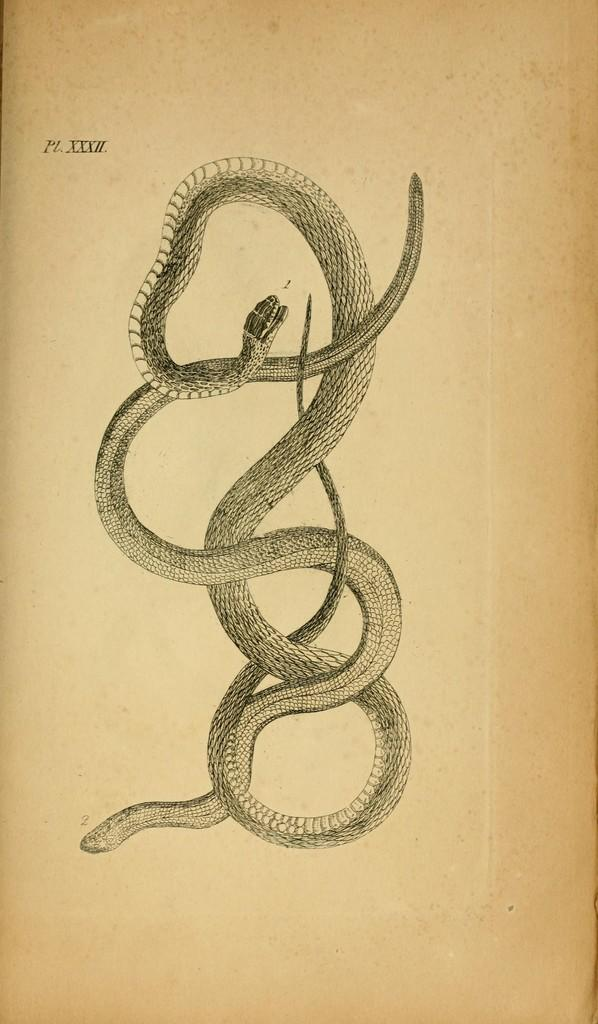What type of visual is the image? The image is a poster. What is depicted in the poster? There is a depiction of snakes in the image. Where is the text located on the poster? The text is on the top of the image. 